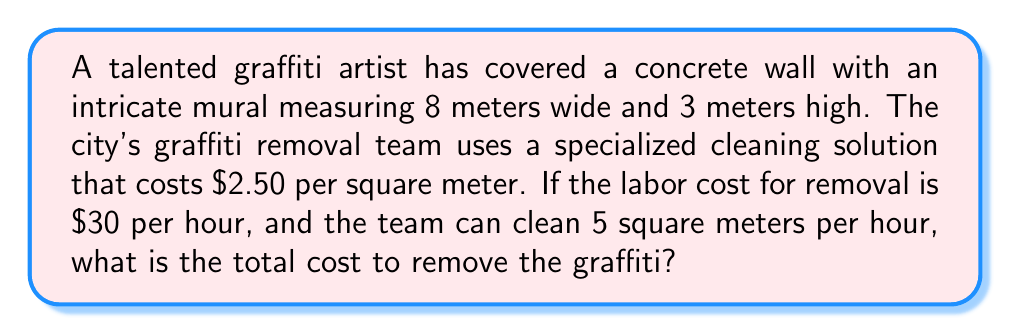Help me with this question. Let's break this down step-by-step:

1. Calculate the total surface area of the graffiti:
   Area = width × height
   $A = 8 \text{ m} \times 3 \text{ m} = 24 \text{ m}^2$

2. Calculate the cost of the cleaning solution:
   Solution cost = Area × Cost per square meter
   $C_s = 24 \text{ m}^2 \times \$2.50/\text{m}^2 = \$60$

3. Calculate the time needed to clean the entire area:
   Time = Total area ÷ Cleaning rate
   $T = 24 \text{ m}^2 \div 5 \text{ m}^2/\text{hour} = 4.8 \text{ hours}$

4. Calculate the labor cost:
   Labor cost = Time × Hourly rate
   $C_l = 4.8 \text{ hours} \times \$30/\text{hour} = \$144$

5. Calculate the total cost by adding the solution cost and labor cost:
   Total cost = Solution cost + Labor cost
   $C_t = C_s + C_l = \$60 + \$144 = \$204$
Answer: $204 